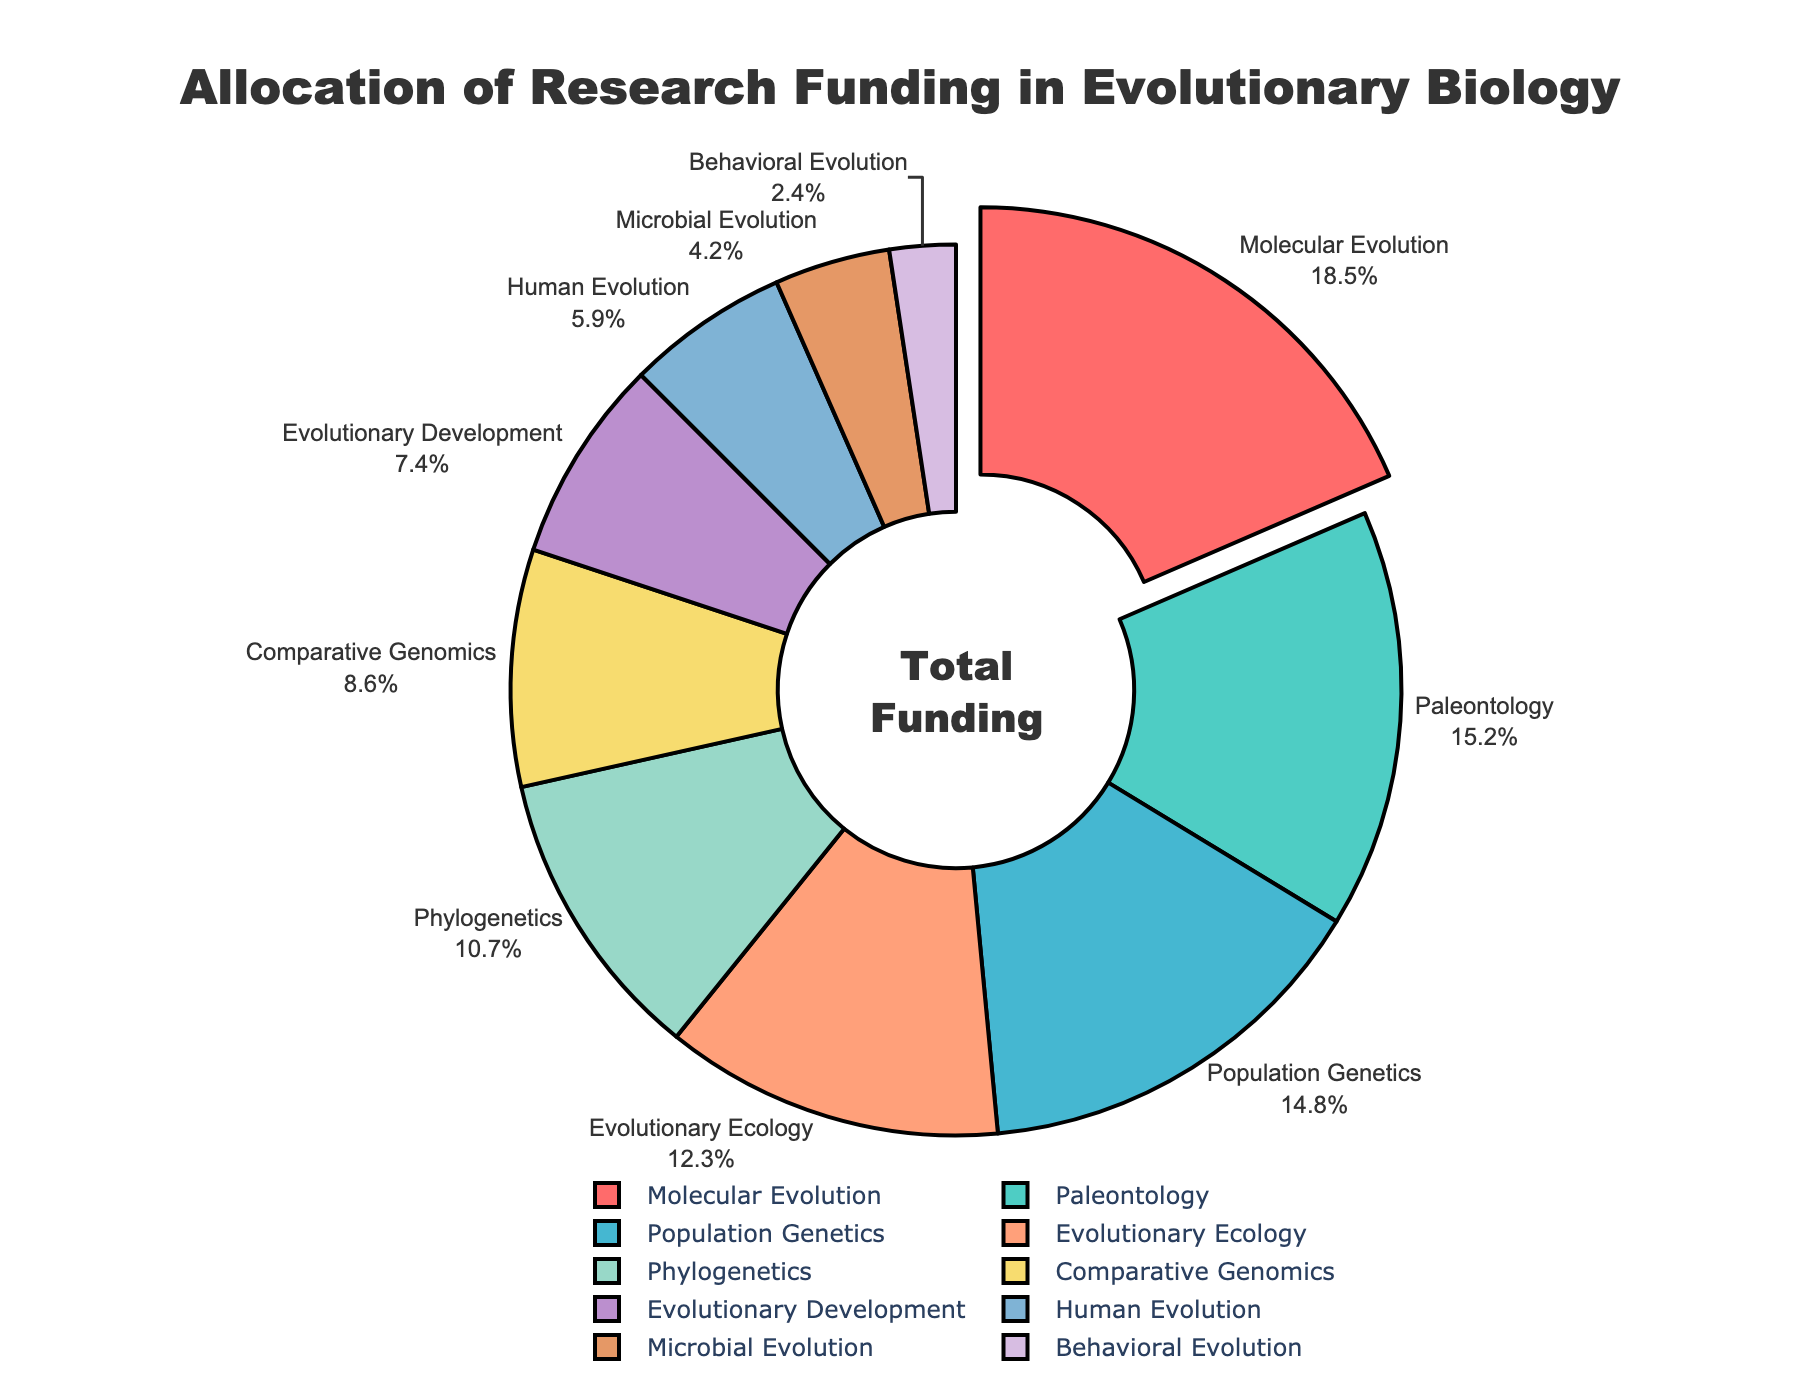What is the largest allocation of research funding among the sub-disciplines? The largest segment of the pie chart, visually pulled out slightly, represents the sub-discipline with the highest funding allocation. This sub-discipline is Molecular Evolution with an 18.5% allocation.
Answer: Molecular Evolution Which sub-discipline receives the least amount of research funding? The smallest segment of the pie chart represents the sub-discipline with the least funding allocation, which is Behavioral Evolution with a 2.4% allocation.
Answer: Behavioral Evolution How much more funding does Molecular Evolution receive compared to Human Evolution? Molecular Evolution receives 18.5% while Human Evolution receives 5.9%. The difference is 18.5% - 5.9% = 12.6%.
Answer: 12.6% What is the combined funding percentage for Population Genetics and Phylogenetics? Population Genetics has 14.8% and Phylogenetics has 10.7%. The combined funding percentage is 14.8% + 10.7% = 25.5%.
Answer: 25.5% Rank the top three sub-disciplines by funding allocation. From the pie chart, the top three sub-disciplines by funding allocation are Molecular Evolution (18.5%), Paleontology (15.2%), and Population Genetics (14.8%).
Answer: Molecular Evolution, Paleontology, Population Genetics Which sub-discipline, Evolutionary Ecology or Comparative Genomics, receives more funding, and by how much? Evolutionary Ecology receives 12.3% while Comparative Genomics receives 8.6%. The difference is 12.3% - 8.6% = 3.7%.
Answer: Evolutionary Ecology by 3.7% What is the average funding percentage across the ten sub-disciplines? Sum all funding percentages: 18.5 + 15.2 + 14.8 + 12.3 + 10.7 + 8.6 + 7.4 + 5.9 + 4.2 + 2.4 = 100. Divide by the number of sub-disciplines: 100 / 10 = 10%.
Answer: 10% What is the ratio of funding between Behavioral Evolution and Molecular Evolution? Behavioral Evolution receives 2.4% and Molecular Evolution receives 18.5%. The ratio is 2.4 / 18.5 = 0.1297, approximately 0.13.
Answer: 0.13 Compare the combined funding of Evolutionary Development and Human Evolution to Evolutionary Ecology funding. Which is greater and by how much? Evolutionary Development has 7.4% and Human Evolution has 5.9%, combined they are 7.4% + 5.9% = 13.3%. Evolutionary Ecology has 12.3%. The combined funding of Evolutionary Development and Human Evolution is greater by 13.3% - 12.3% = 1%.
Answer: Combined funding by 1% Identify the sub-discipline represented by the light purple segment and state its funding percentage. The light purple segment represents Comparative Genomics, which has a funding percentage of 8.6%.
Answer: Comparative Genomics, 8.6% 